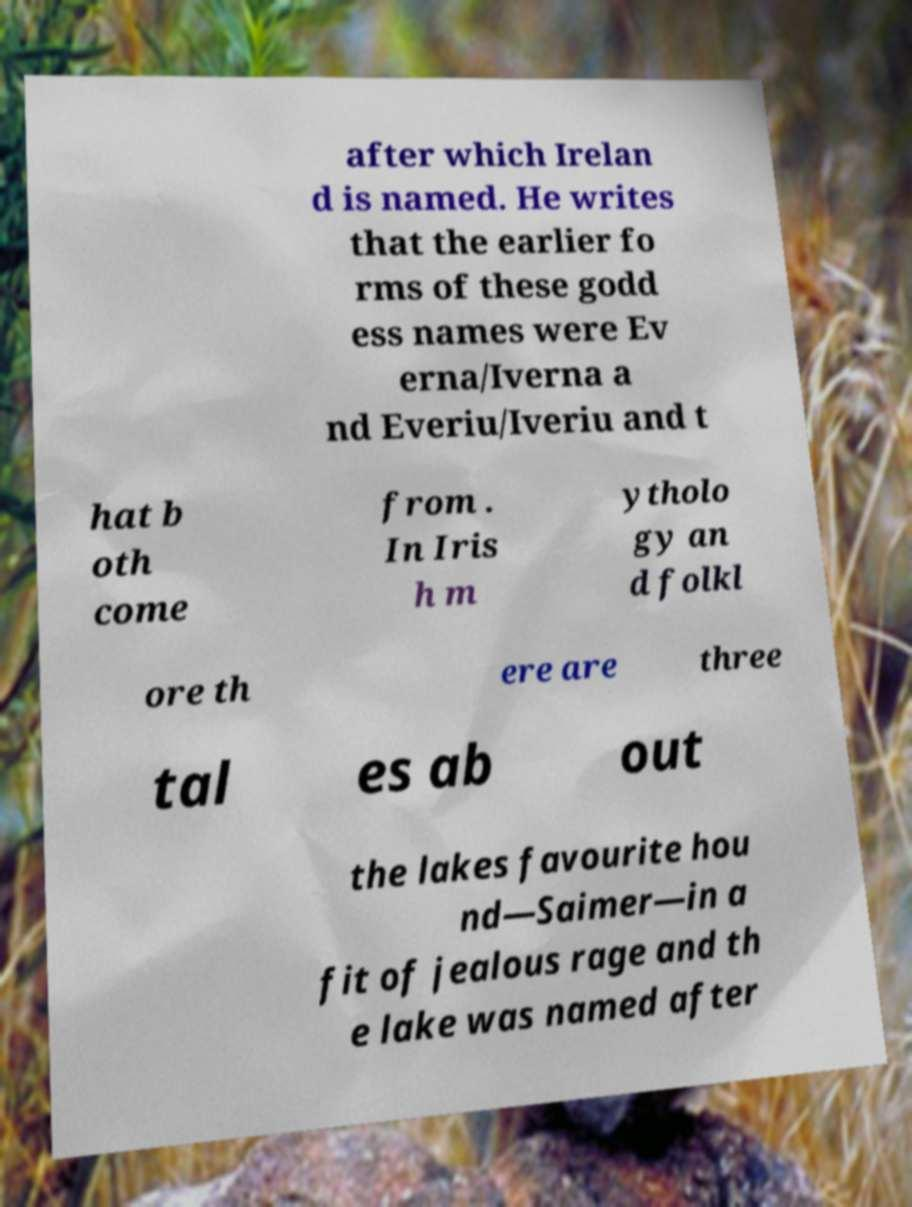Please identify and transcribe the text found in this image. after which Irelan d is named. He writes that the earlier fo rms of these godd ess names were Ev erna/Iverna a nd Everiu/Iveriu and t hat b oth come from . In Iris h m ytholo gy an d folkl ore th ere are three tal es ab out the lakes favourite hou nd—Saimer—in a fit of jealous rage and th e lake was named after 